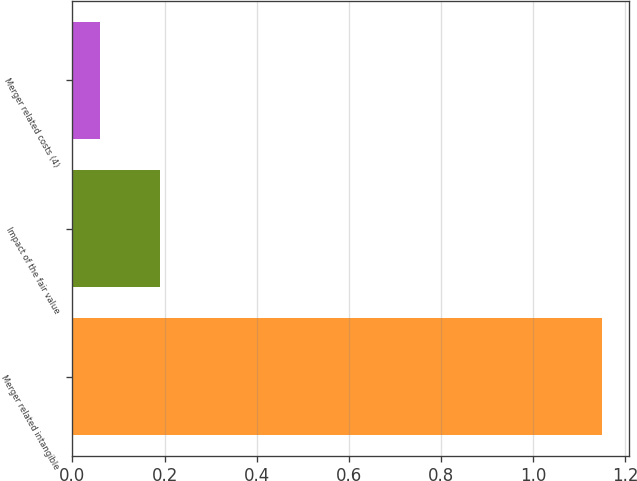Convert chart to OTSL. <chart><loc_0><loc_0><loc_500><loc_500><bar_chart><fcel>Merger related intangible<fcel>Impact of the fair value<fcel>Merger related costs (4)<nl><fcel>1.15<fcel>0.19<fcel>0.06<nl></chart> 